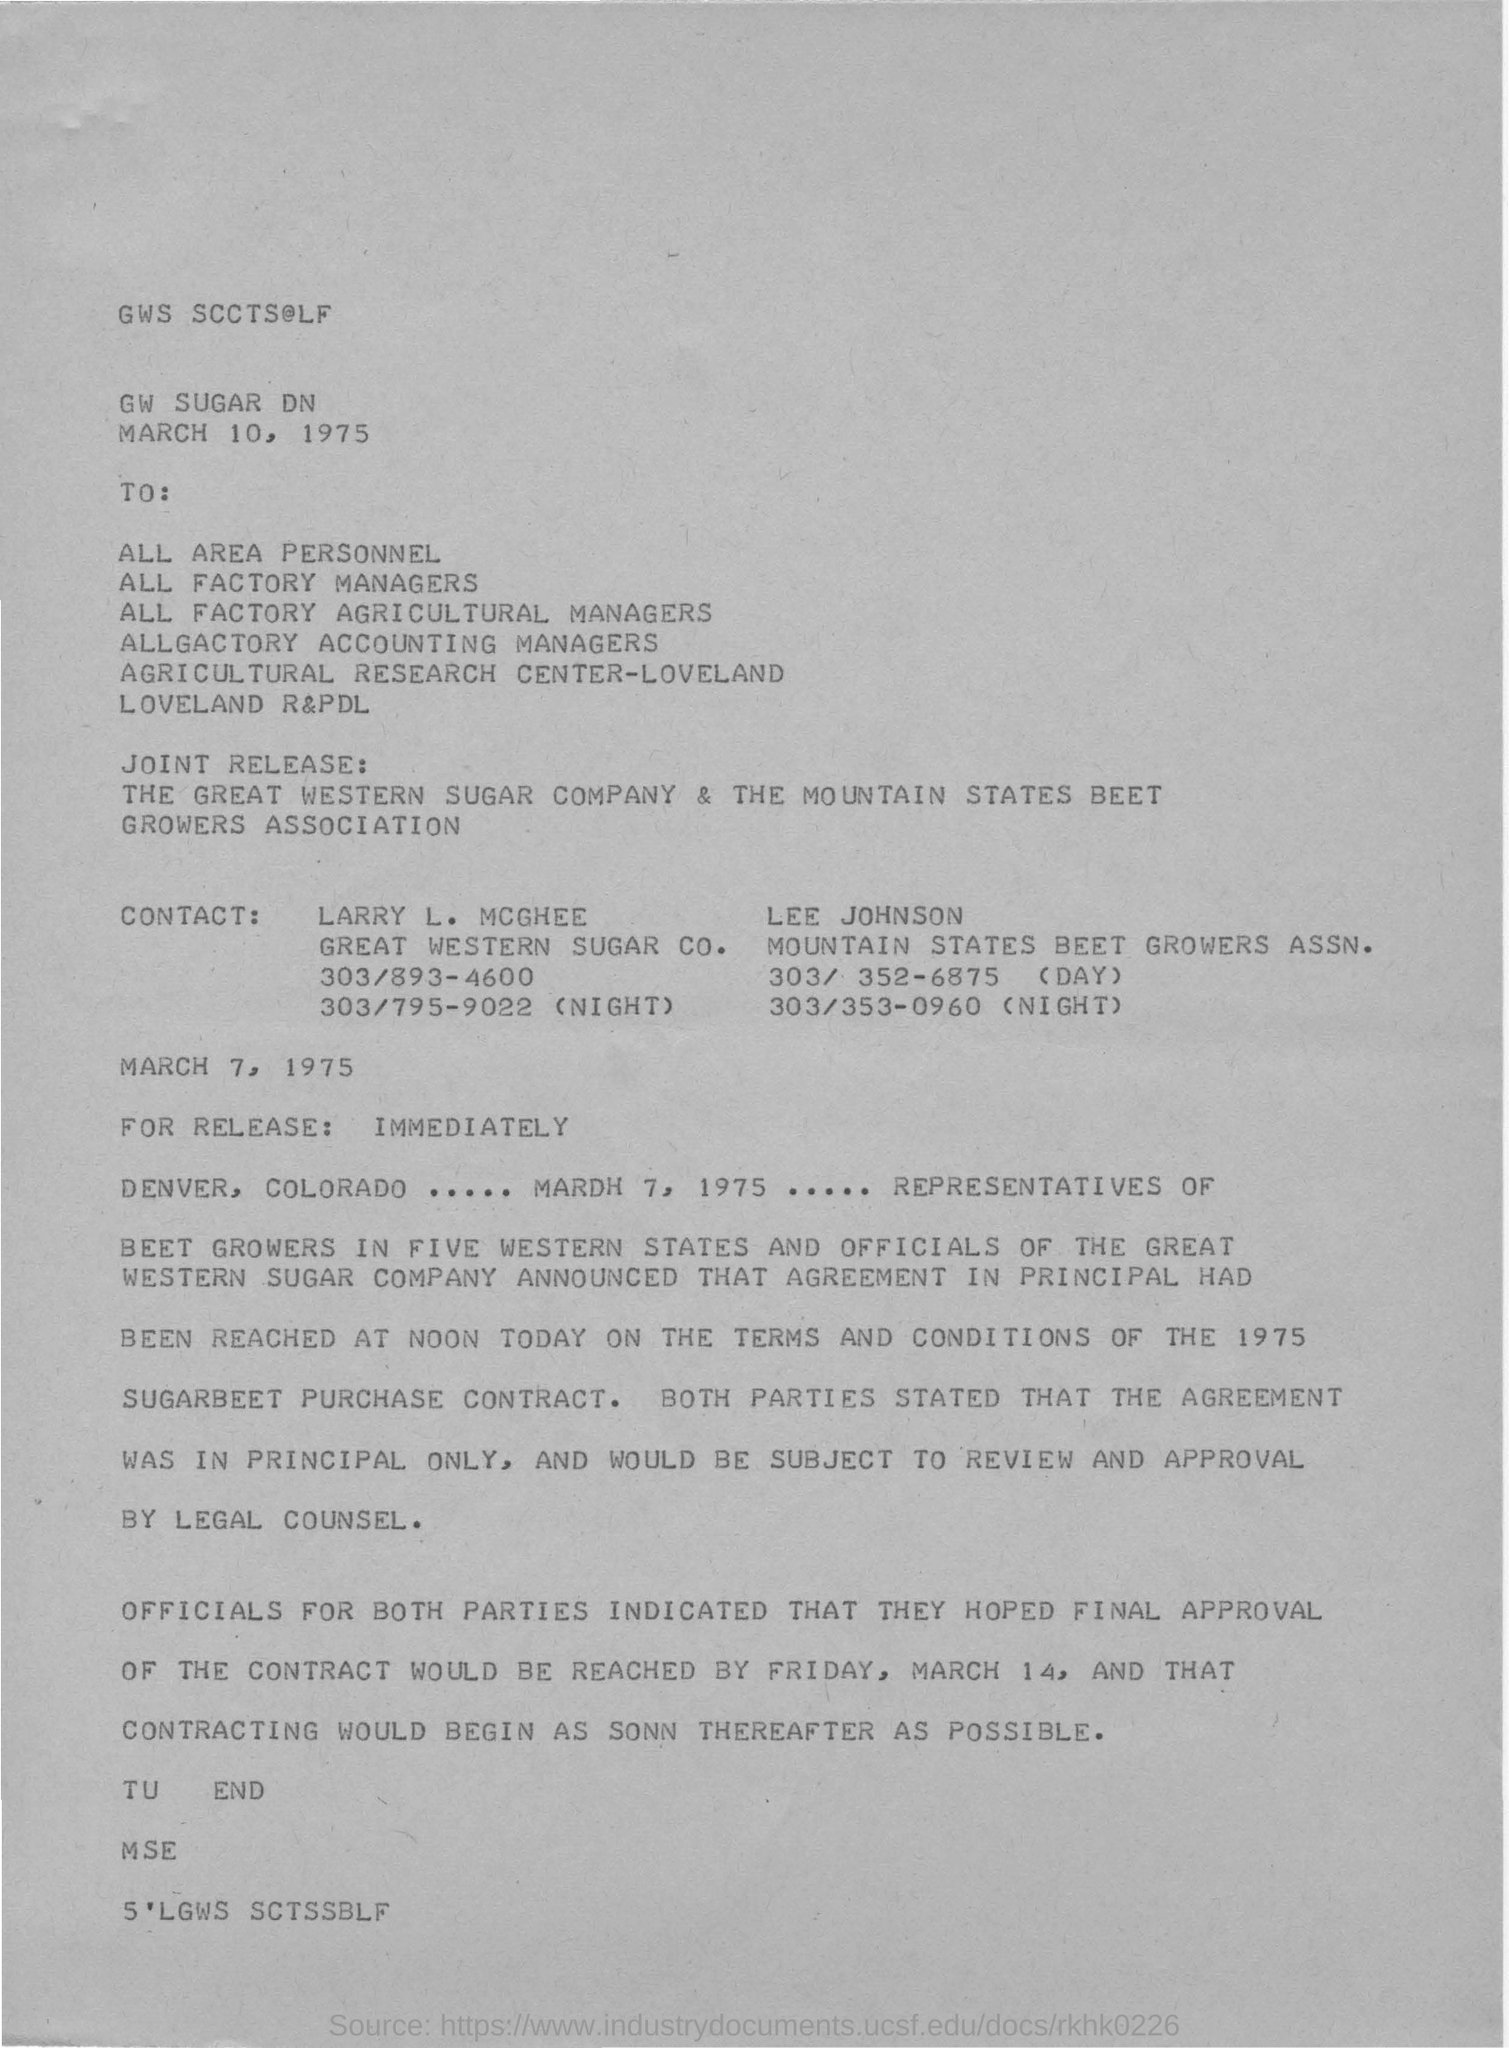What is the date of the letter?
Offer a very short reply. March 10, 1975. Which is the first CONTACT name mentioned?
Your response must be concise. LARRY L. MCGHEE. When is the FINAL APPROVAL of the contract is expected to reach?
Your answer should be compact. MARCH 14. 